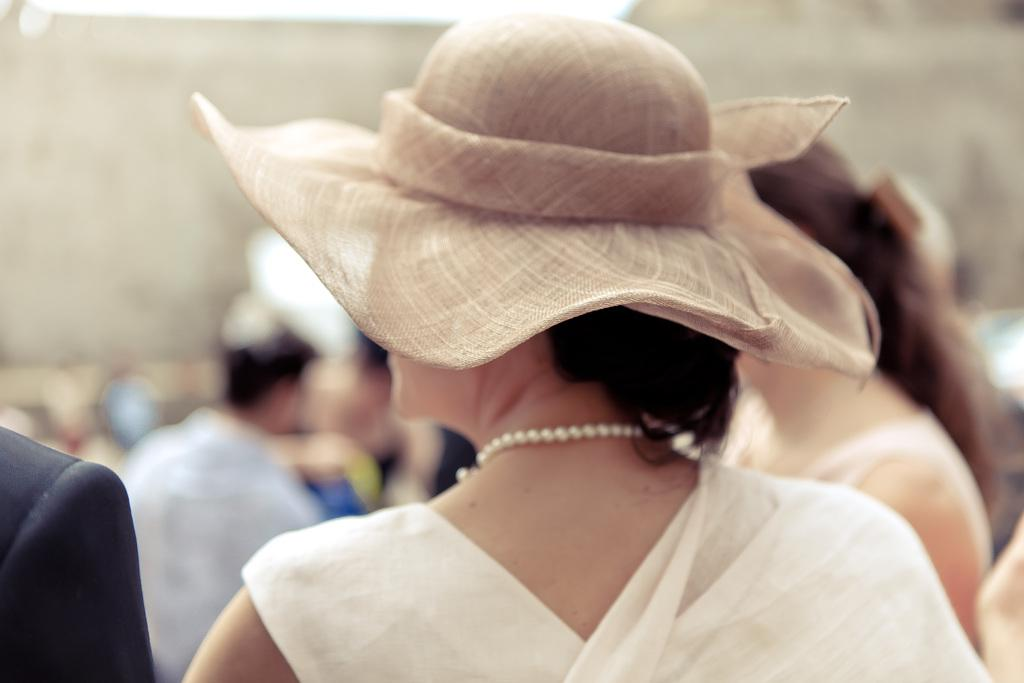What can be seen in the image? There is a person in the image. Can you describe the person's appearance? The person is wearing a hat and has a chain around their neck. Are there any other people in the image? Yes, there are other people behind the person. What type of disgust can be seen on the person's face in the image? There is no indication of disgust on the person's face in the image. 